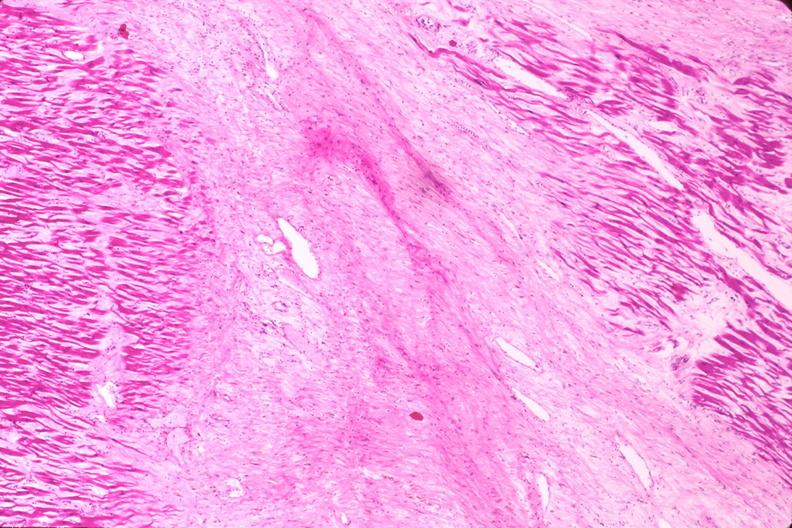s cardiovascular present?
Answer the question using a single word or phrase. Yes 